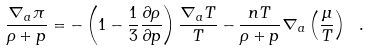Convert formula to latex. <formula><loc_0><loc_0><loc_500><loc_500>\frac { \nabla _ { a } \pi } { \rho + p } = - \left ( 1 - \frac { 1 } { 3 } \frac { \partial { \rho } } { \partial { p } } \right ) \frac { \nabla _ { a } T } { T } - \frac { n T } { \rho + p } \nabla _ { a } \left ( \frac { \mu } { T } \right ) \ .</formula> 